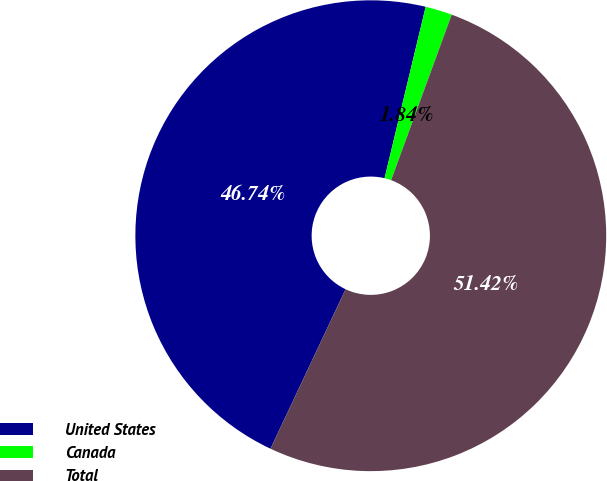Convert chart to OTSL. <chart><loc_0><loc_0><loc_500><loc_500><pie_chart><fcel>United States<fcel>Canada<fcel>Total<nl><fcel>46.74%<fcel>1.84%<fcel>51.42%<nl></chart> 